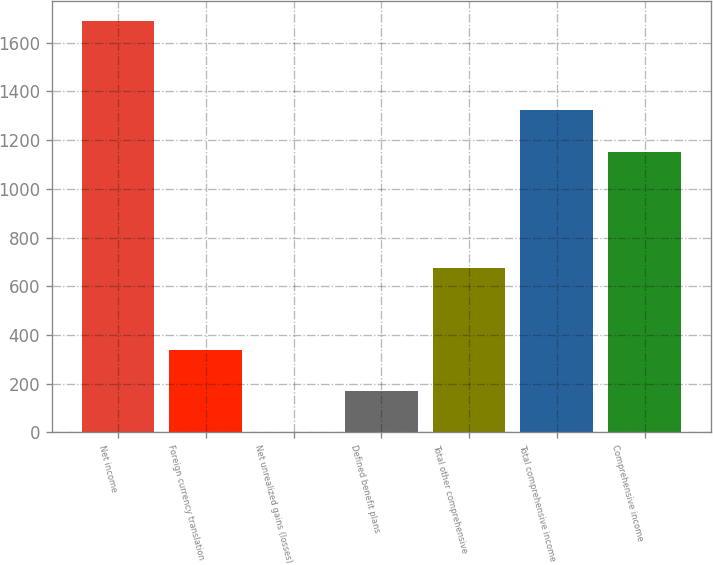Convert chart. <chart><loc_0><loc_0><loc_500><loc_500><bar_chart><fcel>Net income<fcel>Foreign currency translation<fcel>Net unrealized gains (losses)<fcel>Defined benefit plans<fcel>Total other comprehensive<fcel>Total comprehensive income<fcel>Comprehensive income<nl><fcel>1687<fcel>338.2<fcel>1<fcel>169.6<fcel>675.4<fcel>1321.6<fcel>1153<nl></chart> 